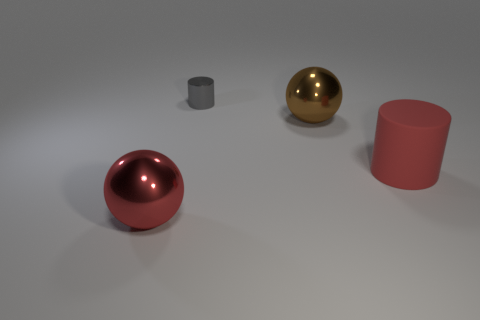There is a gray metallic thing that is the same shape as the large red matte thing; what size is it?
Provide a short and direct response. Small. What number of other large red balls have the same material as the red sphere?
Provide a short and direct response. 0. Are there fewer large red metallic things that are left of the big red rubber cylinder than gray cubes?
Your answer should be very brief. No. How many gray cylinders are there?
Offer a terse response. 1. What number of large metallic objects have the same color as the matte thing?
Ensure brevity in your answer.  1. Is the shape of the matte thing the same as the small gray thing?
Keep it short and to the point. Yes. There is a metallic ball that is behind the object in front of the large red cylinder; how big is it?
Provide a short and direct response. Large. Is there a brown shiny thing of the same size as the gray thing?
Make the answer very short. No. There is a sphere that is in front of the red cylinder; is it the same size as the red object on the right side of the big brown metal object?
Ensure brevity in your answer.  Yes. There is a large metallic object on the right side of the ball that is to the left of the gray metal object; what shape is it?
Make the answer very short. Sphere. 